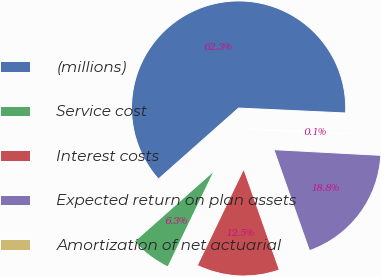Convert chart. <chart><loc_0><loc_0><loc_500><loc_500><pie_chart><fcel>(millions)<fcel>Service cost<fcel>Interest costs<fcel>Expected return on plan assets<fcel>Amortization of net actuarial<nl><fcel>62.27%<fcel>6.32%<fcel>12.54%<fcel>18.76%<fcel>0.11%<nl></chart> 